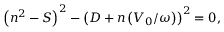<formula> <loc_0><loc_0><loc_500><loc_500>\left ( n ^ { 2 } - S \right ) ^ { 2 } - \left ( D + n \left ( V _ { 0 } / \omega \right ) \right ) ^ { 2 } = 0 ,</formula> 